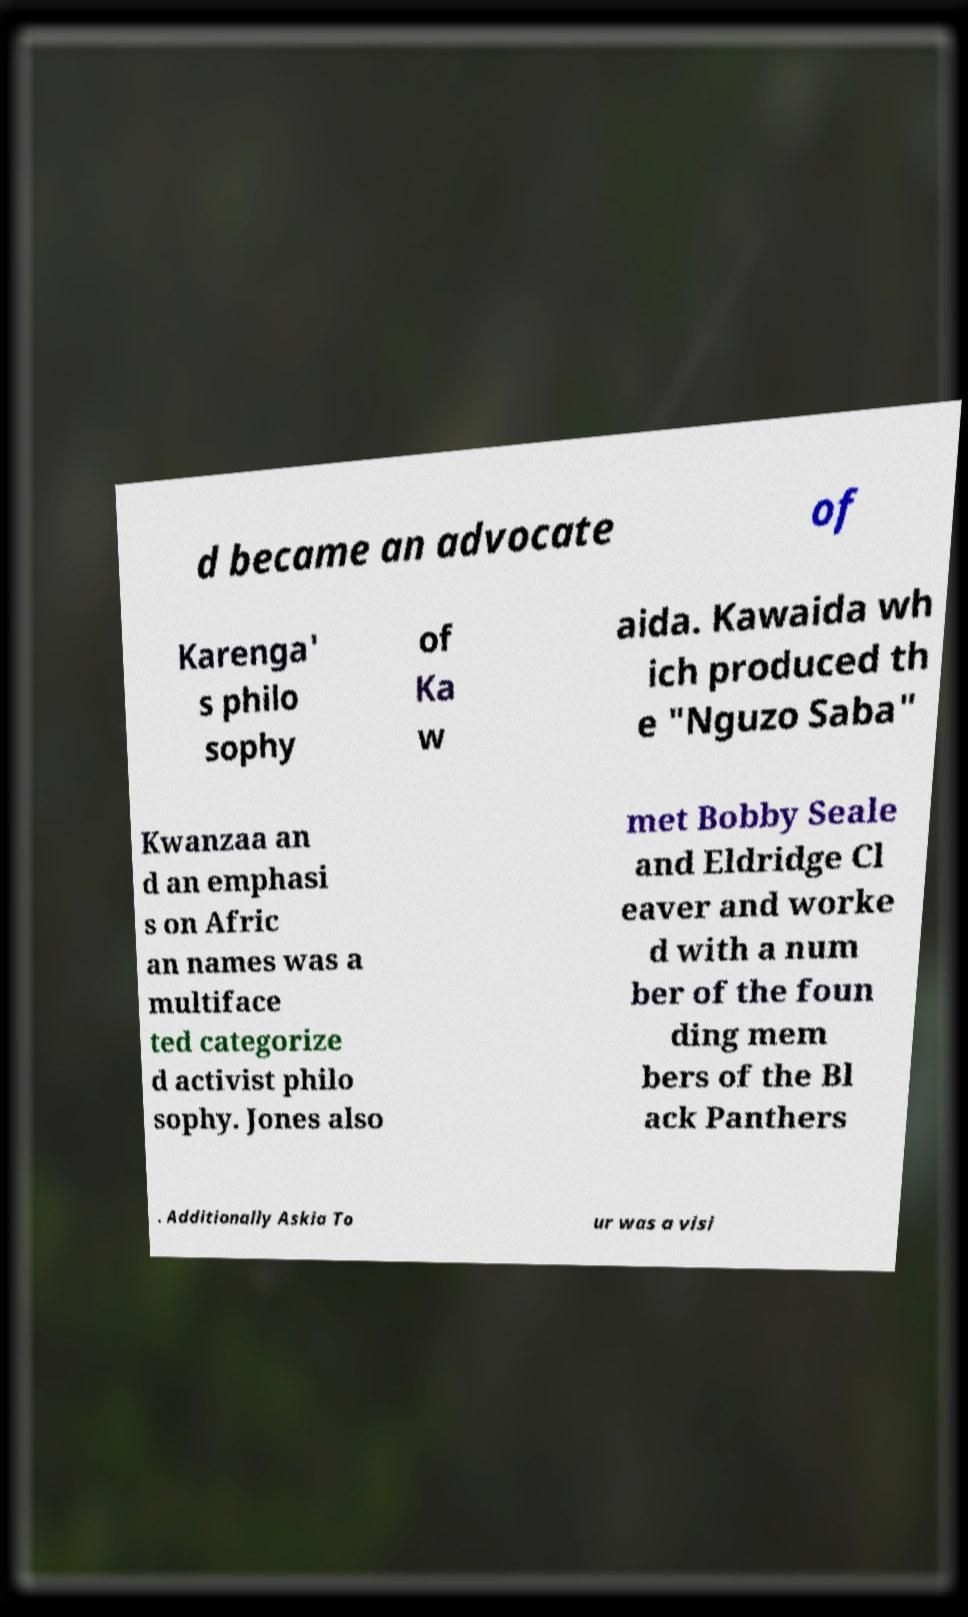There's text embedded in this image that I need extracted. Can you transcribe it verbatim? d became an advocate of Karenga' s philo sophy of Ka w aida. Kawaida wh ich produced th e "Nguzo Saba" Kwanzaa an d an emphasi s on Afric an names was a multiface ted categorize d activist philo sophy. Jones also met Bobby Seale and Eldridge Cl eaver and worke d with a num ber of the foun ding mem bers of the Bl ack Panthers . Additionally Askia To ur was a visi 